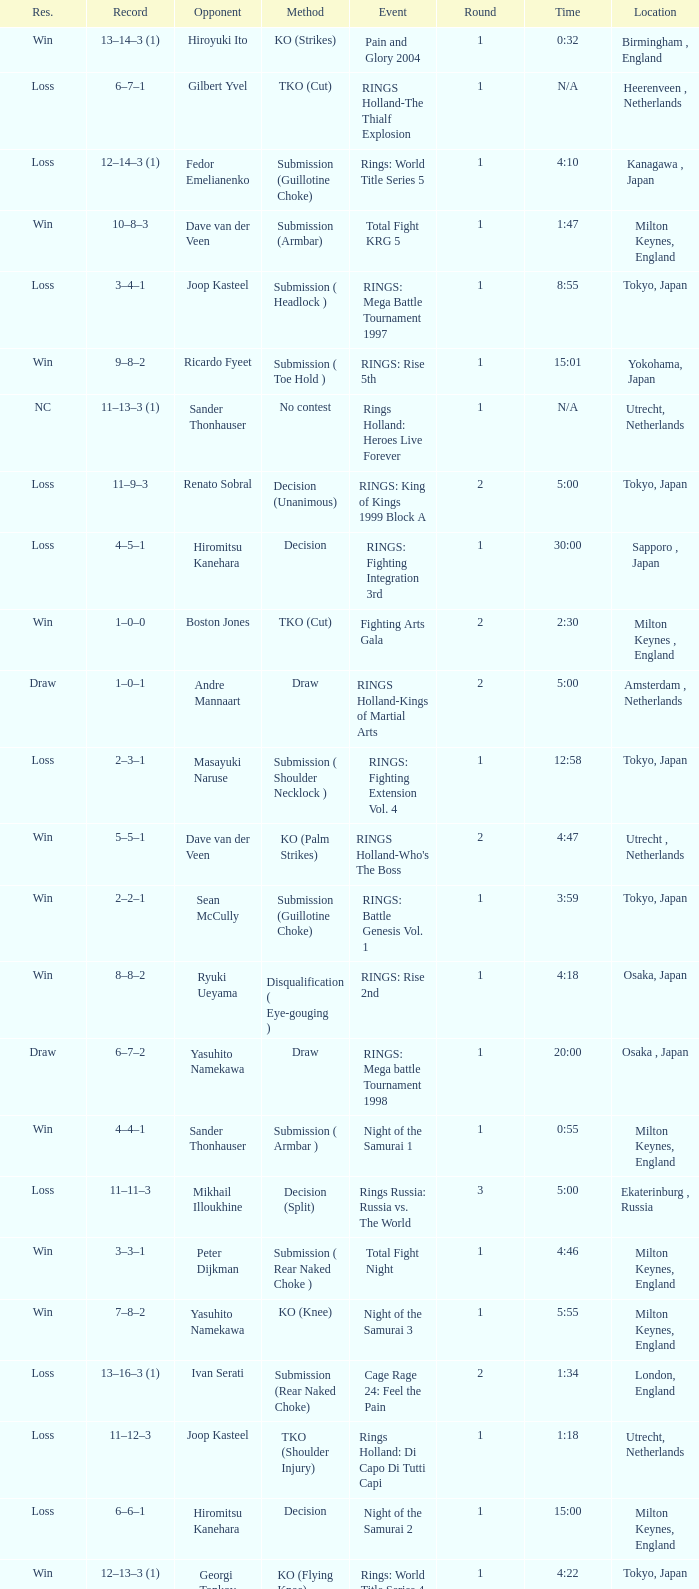Who was the opponent in London, England in a round less than 2? Mario Sperry. 